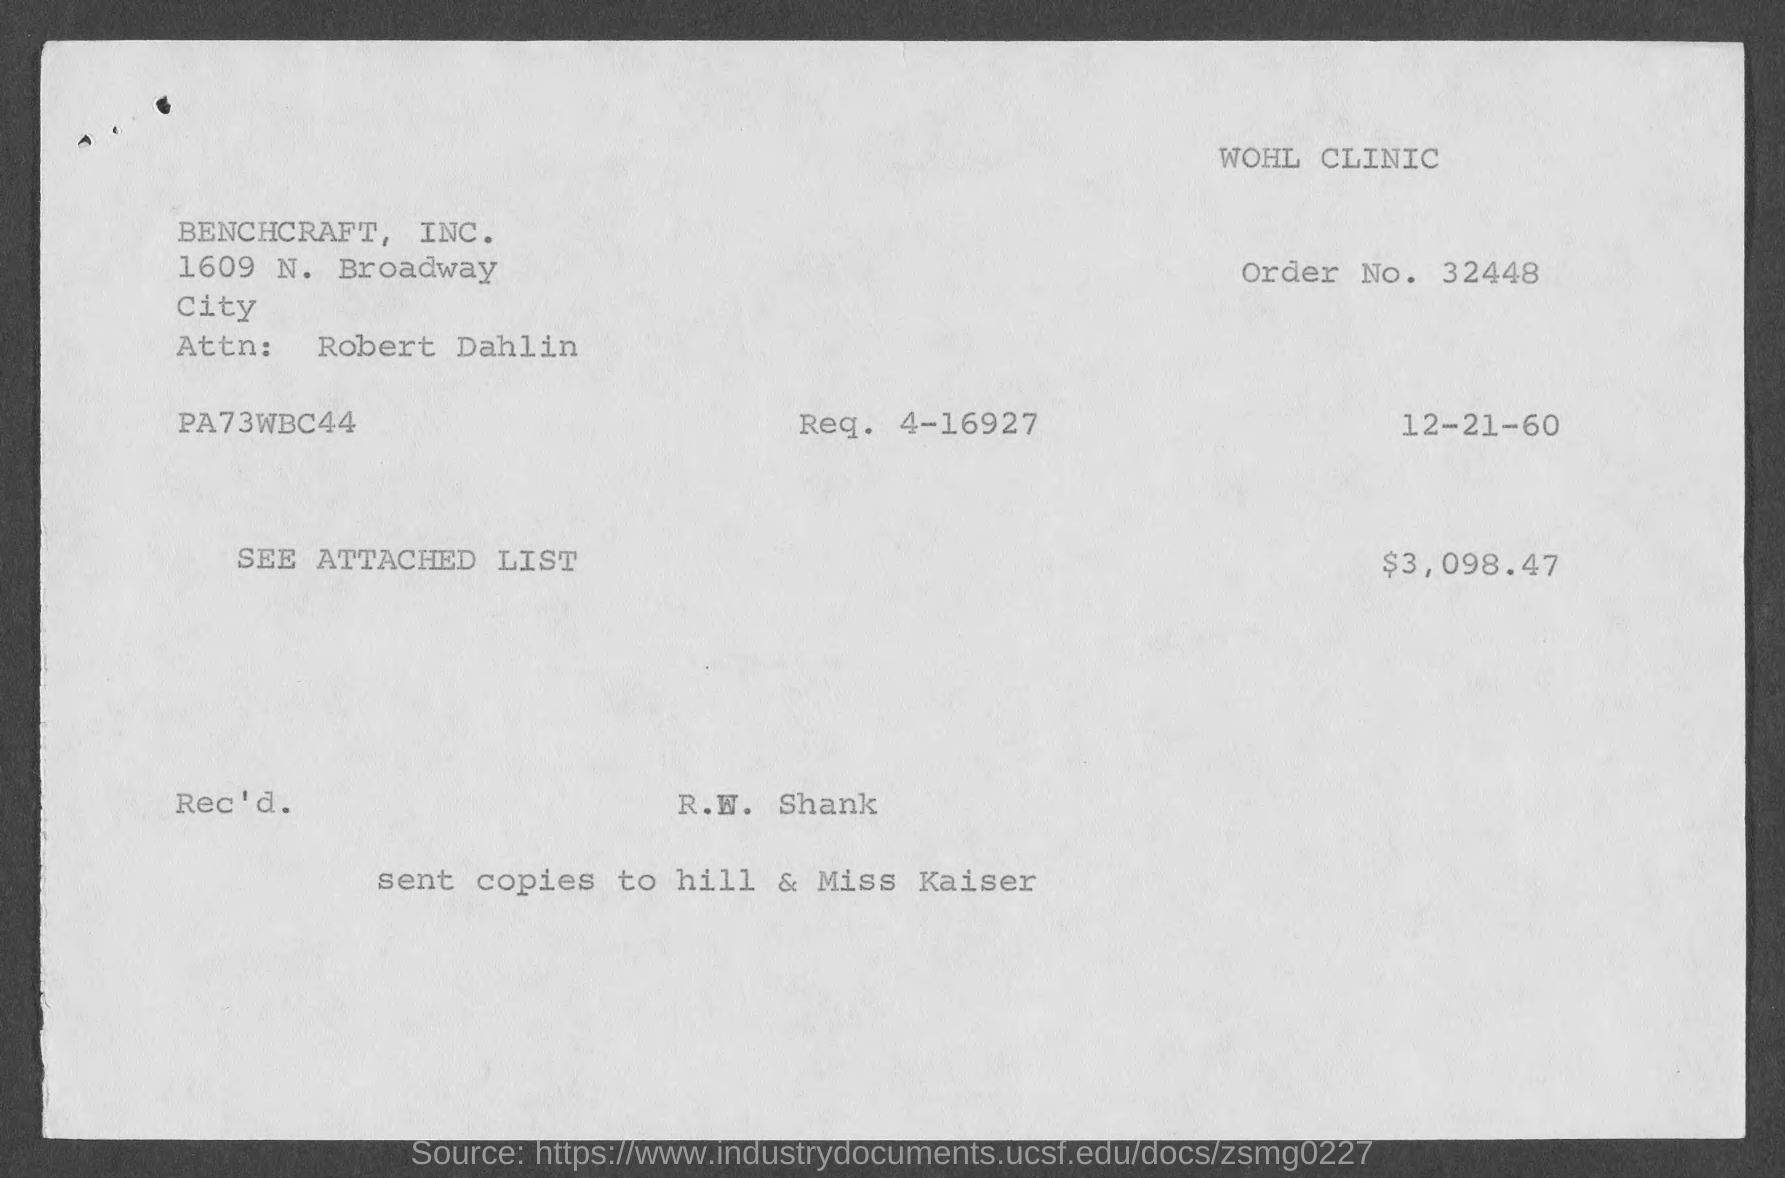What is the Order No.?
Your answer should be very brief. 32448. What is the date on the document?
Provide a succinct answer. 12-21-60. Who is the Attn: to?
Give a very brief answer. Robert Dahlin. Who is it Rec'd by?
Offer a very short reply. R.W. Shank. 